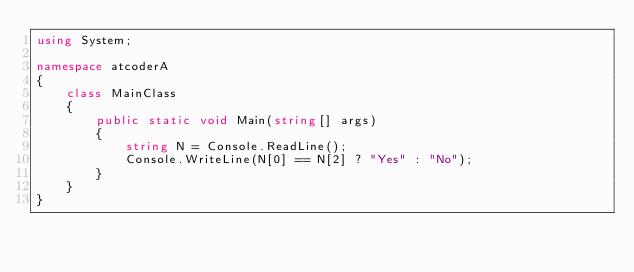<code> <loc_0><loc_0><loc_500><loc_500><_C#_>using System;

namespace atcoderA
{
    class MainClass
    {
        public static void Main(string[] args)
        {
            string N = Console.ReadLine();
            Console.WriteLine(N[0] == N[2] ? "Yes" : "No");
        }
    }
}</code> 